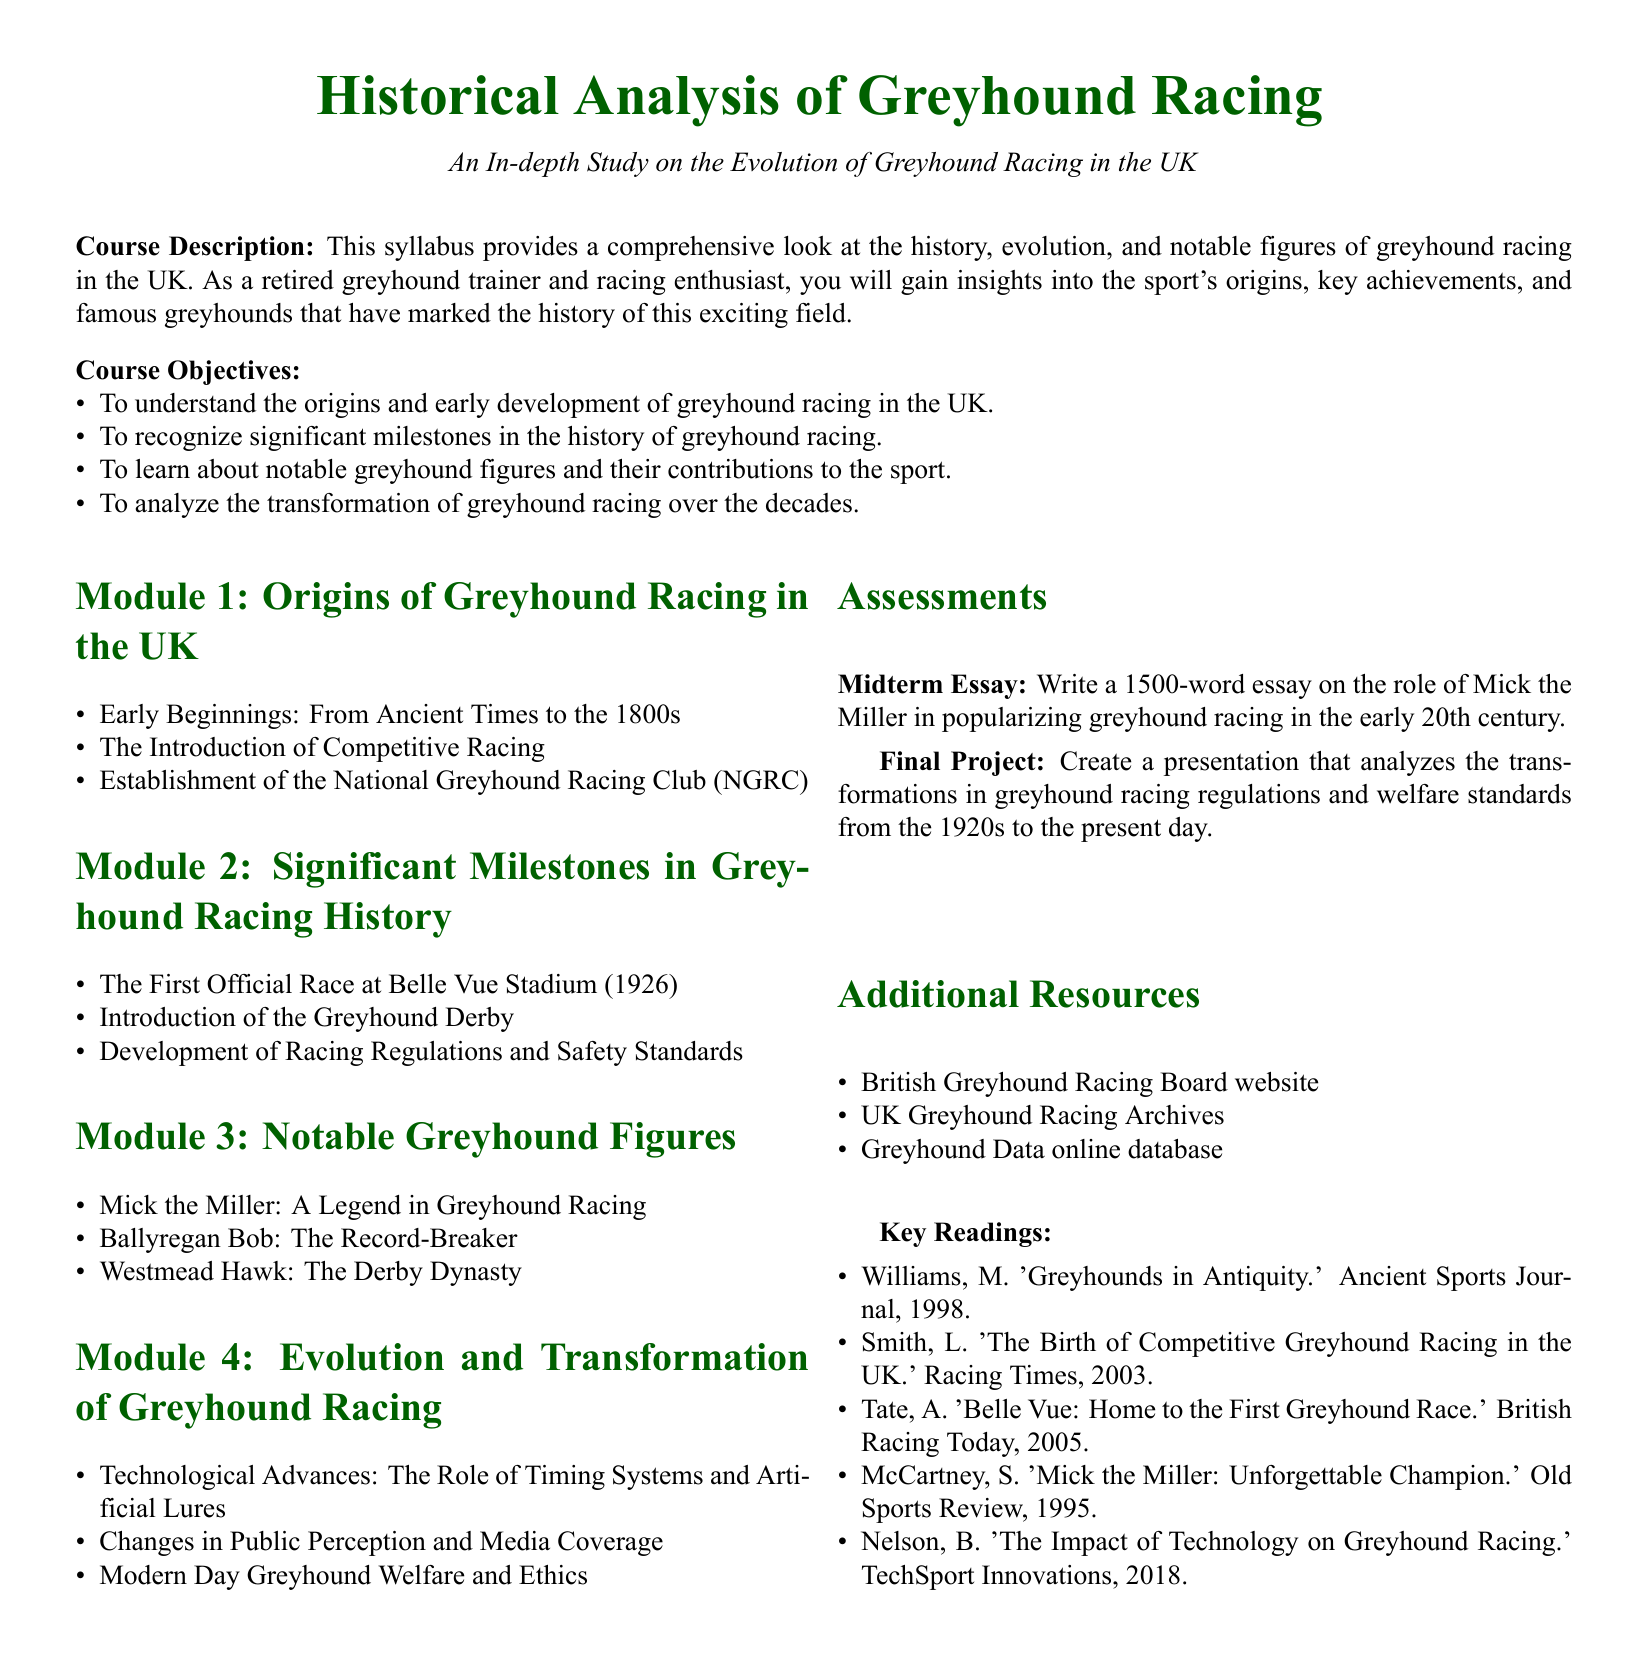what is the course title? The course title is given at the beginning of the document, clearly stating the subject being studied.
Answer: Historical Analysis of Greyhound Racing what is the aim of Module 1? The aim is to explore the origins and early development of greyhound racing in the UK, which includes various topics outlined in that module.
Answer: Origins of Greyhound Racing in the UK who was a legend in greyhound racing mentioned in Module 3? This question specifically relates to notable greyhound figures discussed in the syllabus.
Answer: Mick the Miller when was the first official race at Belle Vue Stadium? This information is provided within the significant milestones section of the syllabus.
Answer: 1926 what is the word count for the midterm essay? The syllabus specifies a word count for an assignment, detailing requirements for students.
Answer: 1500-word what does the final project involve? The final project is described in the assessments section, outlining what students need to create.
Answer: Create a presentation which online database is mentioned as a resource? This question covers the additional resources listed in the document, focusing on the educational components provided.
Answer: Greyhound Data what technology's impact is discussed in Module 4? This question requires understanding of the content covered in the module, which focuses on advances in greyhound racing.
Answer: Timing Systems and Artificial Lures 